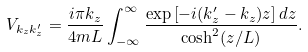Convert formula to latex. <formula><loc_0><loc_0><loc_500><loc_500>V _ { k _ { z } k _ { z } ^ { \prime } } = \frac { i \pi k _ { z } } { 4 m L } \int _ { - \infty } ^ { \infty } \frac { \exp \left [ - i ( k _ { z } ^ { \prime } - k _ { z } ) z \right ] d z } { \cosh ^ { 2 } ( z / L ) } .</formula> 